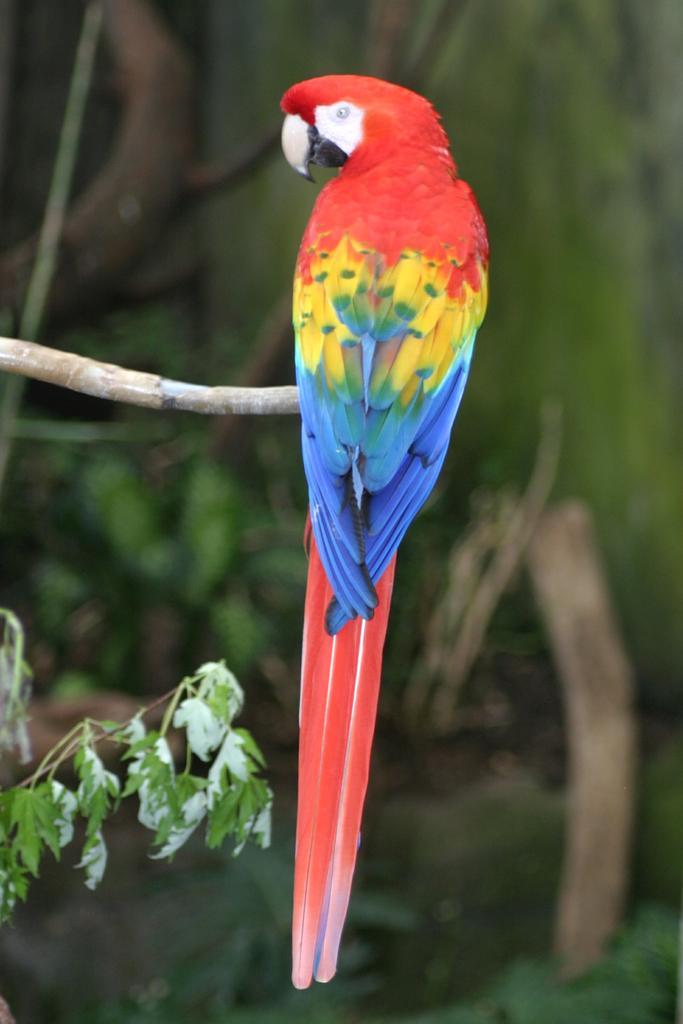In one or two sentences, can you explain what this image depicts? In this image in the foreground there is one bird on a tree, and there is blurry background. 